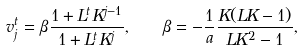Convert formula to latex. <formula><loc_0><loc_0><loc_500><loc_500>v ^ { t } _ { j } = \beta \frac { 1 + L ^ { t } K ^ { j - 1 } } { 1 + L ^ { t } K ^ { j } } , \quad \beta = - \frac { 1 } { a } \frac { K ( L K - 1 ) } { L K ^ { 2 } - 1 } ,</formula> 